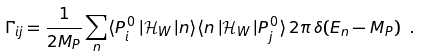Convert formula to latex. <formula><loc_0><loc_0><loc_500><loc_500>\Gamma _ { i j } = \frac { 1 } { 2 M _ { P } } \sum _ { n } \langle P ^ { \, 0 } _ { i } \, | \mathcal { H } _ { W } \, | n \rangle \langle n \, | \mathcal { H } _ { W } \, | P ^ { \, 0 } _ { j } \rangle \, 2 \pi \, \delta ( E _ { n } - M _ { P } ) \ .</formula> 